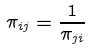<formula> <loc_0><loc_0><loc_500><loc_500>\pi _ { i j } = \frac { 1 } { \pi _ { j i } }</formula> 